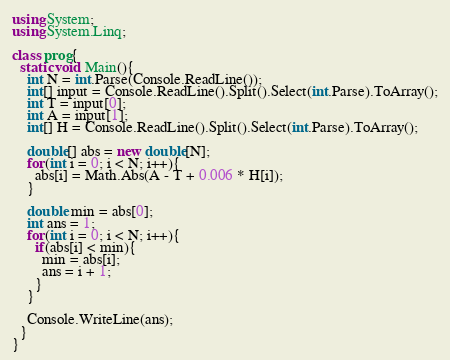<code> <loc_0><loc_0><loc_500><loc_500><_C#_>using System;
using System.Linq;

class prog{
  static void Main(){
    int N = int.Parse(Console.ReadLine());
    int[] input = Console.ReadLine().Split().Select(int.Parse).ToArray();
    int T = input[0];
    int A = input[1];
    int[] H = Console.ReadLine().Split().Select(int.Parse).ToArray();
    
    double[] abs = new double[N];
    for(int i = 0; i < N; i++){
      abs[i] = Math.Abs(A - T + 0.006 * H[i]);
    }
    
    double min = abs[0];
    int ans = 1;
    for(int i = 0; i < N; i++){
      if(abs[i] < min){
        min = abs[i];
        ans = i + 1;
      }
    }
    
    Console.WriteLine(ans);
  }
}</code> 